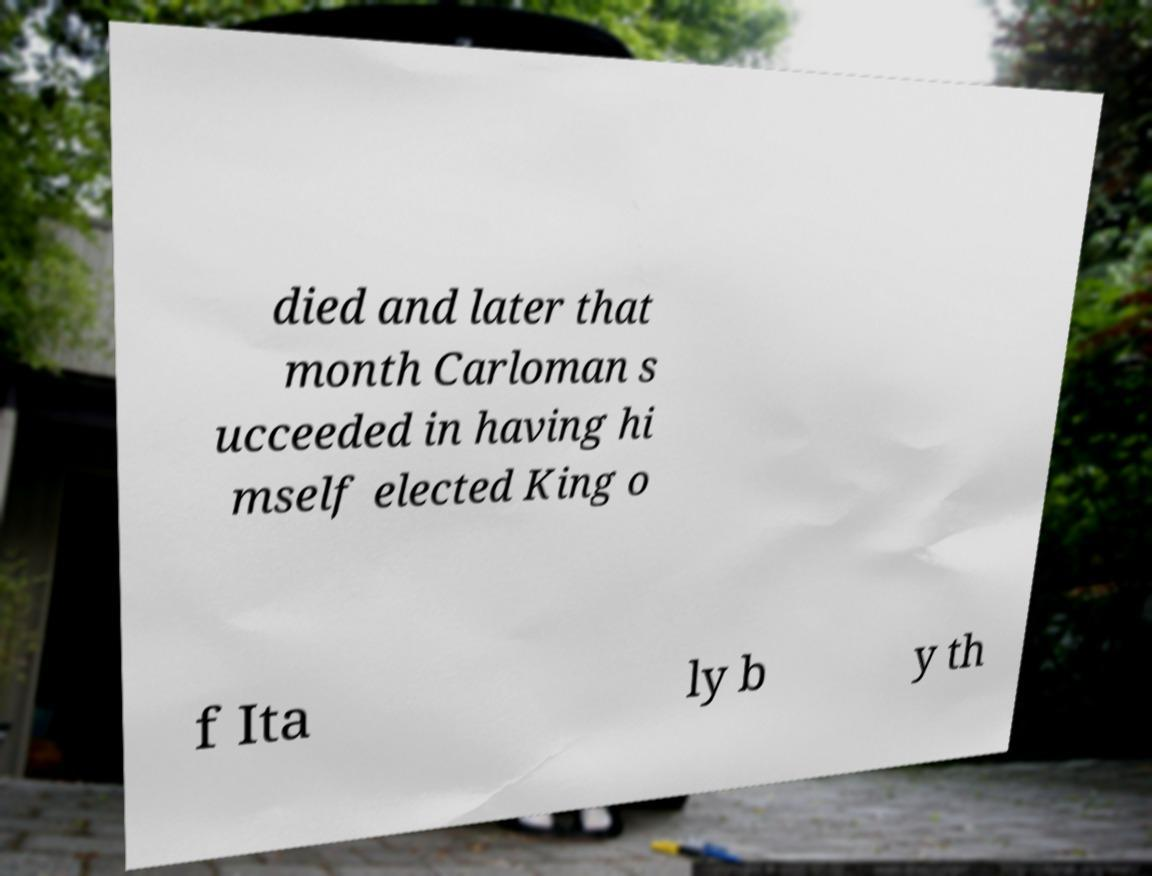For documentation purposes, I need the text within this image transcribed. Could you provide that? died and later that month Carloman s ucceeded in having hi mself elected King o f Ita ly b y th 